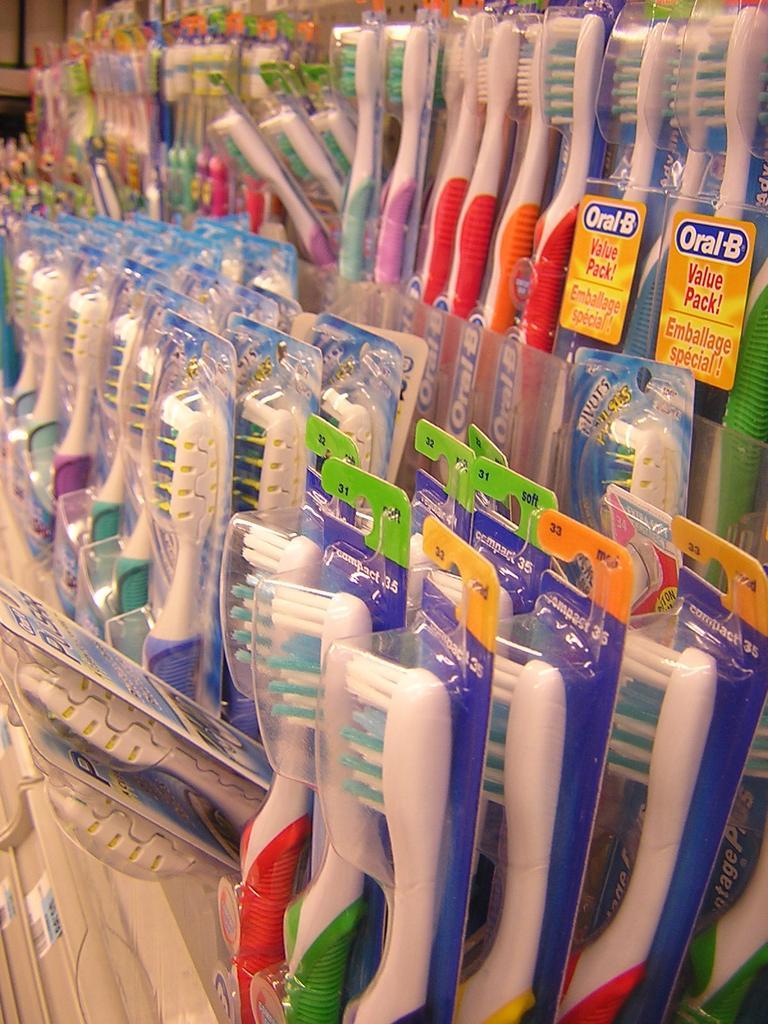How would you summarize this image in a sentence or two? In this image there are so many bunch of packaged toothbrushes. 